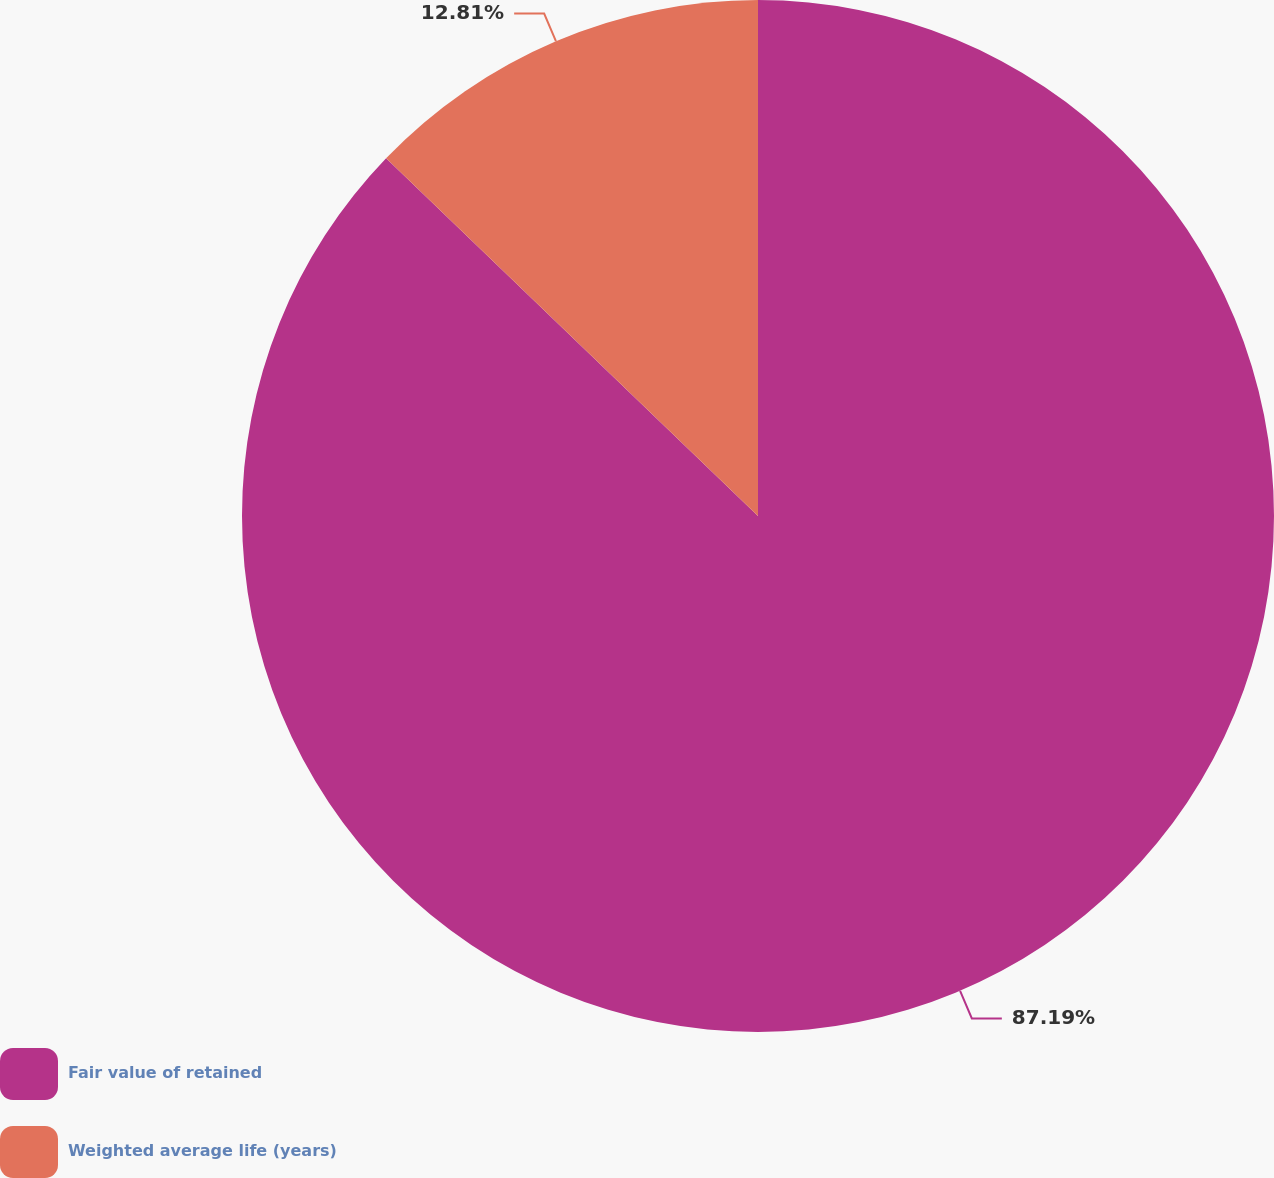Convert chart to OTSL. <chart><loc_0><loc_0><loc_500><loc_500><pie_chart><fcel>Fair value of retained<fcel>Weighted average life (years)<nl><fcel>87.19%<fcel>12.81%<nl></chart> 